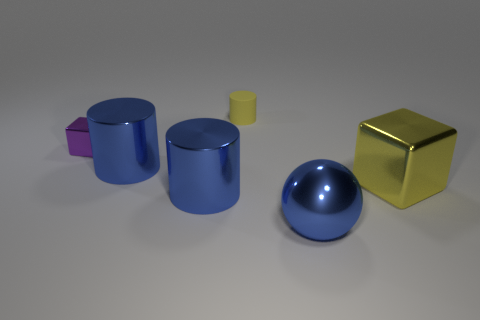There is a tiny metal block that is behind the block right of the big metal sphere; is there a purple block in front of it?
Your response must be concise. No. The large yellow thing has what shape?
Provide a short and direct response. Cube. Does the tiny thing that is right of the tiny metallic thing have the same material as the small purple thing behind the large shiny sphere?
Your answer should be very brief. No. What number of tiny metallic cubes are the same color as the large ball?
Give a very brief answer. 0. There is a shiny object that is both behind the yellow metallic object and to the right of the small cube; what shape is it?
Keep it short and to the point. Cylinder. The object that is both on the right side of the small rubber object and to the left of the large yellow object is what color?
Provide a succinct answer. Blue. Is the number of small purple metallic blocks that are right of the small rubber object greater than the number of small objects that are in front of the tiny metal cube?
Offer a very short reply. No. There is a cube that is to the left of the rubber cylinder; what is its color?
Offer a terse response. Purple. There is a blue thing that is on the right side of the matte object; is it the same shape as the yellow thing behind the purple thing?
Provide a succinct answer. No. Are there any red metallic cylinders that have the same size as the matte thing?
Provide a succinct answer. No. 